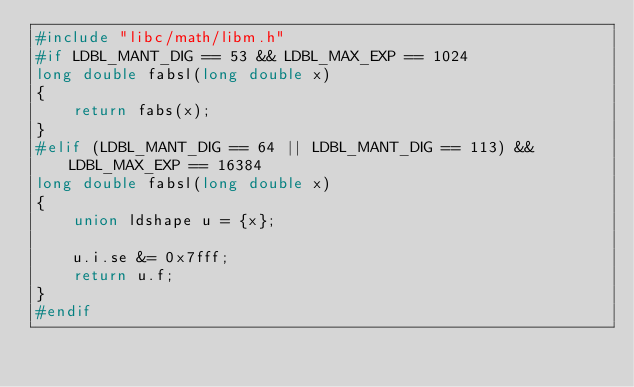Convert code to text. <code><loc_0><loc_0><loc_500><loc_500><_C_>#include "libc/math/libm.h"
#if LDBL_MANT_DIG == 53 && LDBL_MAX_EXP == 1024
long double fabsl(long double x)
{
	return fabs(x);
}
#elif (LDBL_MANT_DIG == 64 || LDBL_MANT_DIG == 113) && LDBL_MAX_EXP == 16384
long double fabsl(long double x)
{
	union ldshape u = {x};

	u.i.se &= 0x7fff;
	return u.f;
}
#endif
</code> 